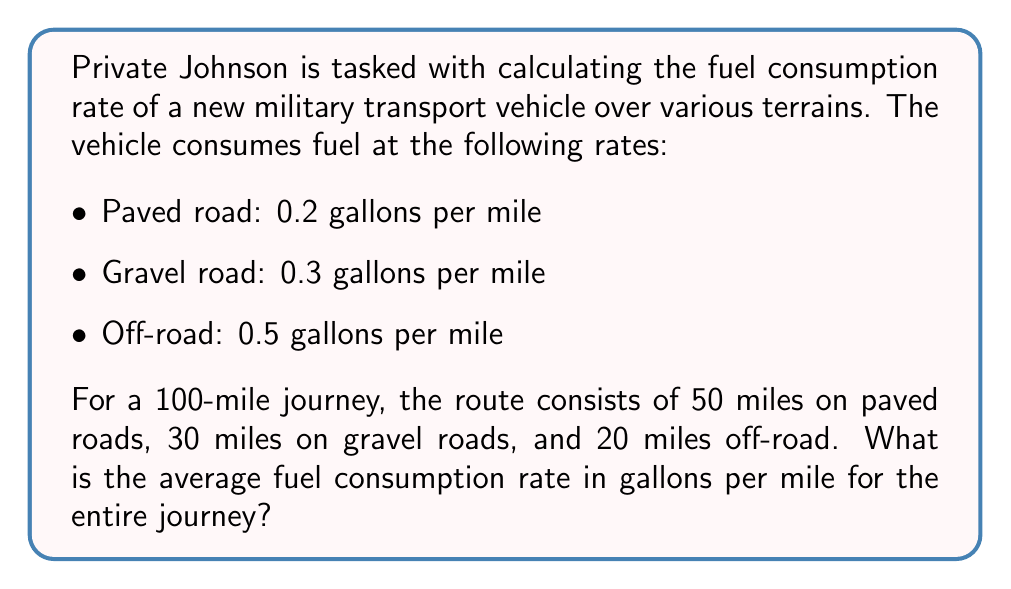Help me with this question. To solve this problem, we need to:
1. Calculate the total fuel consumed for each terrain type
2. Sum up the total fuel consumed for the entire journey
3. Divide the total fuel consumed by the total distance to get the average consumption rate

Let's break it down step-by-step:

1. Fuel consumed on each terrain type:
   - Paved road: $50 \text{ miles} \times 0.2 \text{ gal/mile} = 10 \text{ gallons}$
   - Gravel road: $30 \text{ miles} \times 0.3 \text{ gal/mile} = 9 \text{ gallons}$
   - Off-road: $20 \text{ miles} \times 0.5 \text{ gal/mile} = 10 \text{ gallons}$

2. Total fuel consumed:
   $$\text{Total fuel} = 10 + 9 + 10 = 29 \text{ gallons}$$

3. Average fuel consumption rate:
   $$\text{Average rate} = \frac{\text{Total fuel consumed}}{\text{Total distance}}$$
   $$= \frac{29 \text{ gallons}}{100 \text{ miles}}$$
   $$= 0.29 \text{ gallons per mile}$$

Therefore, the average fuel consumption rate for the entire journey is 0.29 gallons per mile.
Answer: 0.29 gallons per mile 